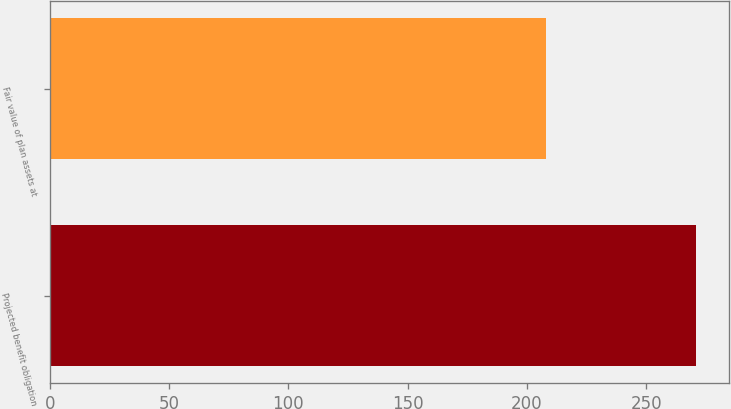Convert chart to OTSL. <chart><loc_0><loc_0><loc_500><loc_500><bar_chart><fcel>Projected benefit obligation<fcel>Fair value of plan assets at<nl><fcel>271<fcel>208<nl></chart> 